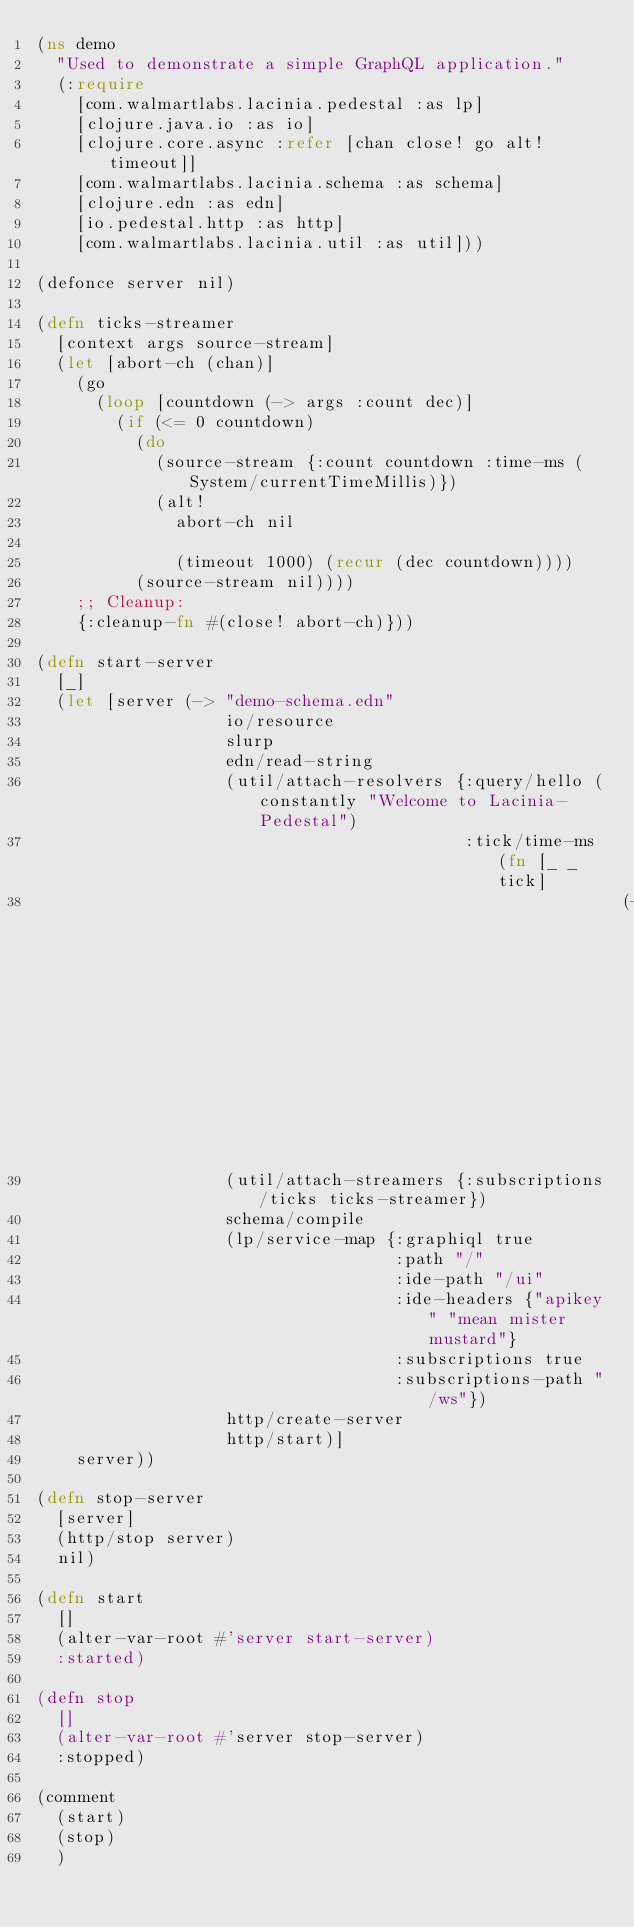<code> <loc_0><loc_0><loc_500><loc_500><_Clojure_>(ns demo
  "Used to demonstrate a simple GraphQL application."
  (:require
    [com.walmartlabs.lacinia.pedestal :as lp]
    [clojure.java.io :as io]
    [clojure.core.async :refer [chan close! go alt! timeout]]
    [com.walmartlabs.lacinia.schema :as schema]
    [clojure.edn :as edn]
    [io.pedestal.http :as http]
    [com.walmartlabs.lacinia.util :as util]))

(defonce server nil)

(defn ticks-streamer
  [context args source-stream]
  (let [abort-ch (chan)]
    (go
      (loop [countdown (-> args :count dec)]
        (if (<= 0 countdown)
          (do
            (source-stream {:count countdown :time-ms (System/currentTimeMillis)})
            (alt!
              abort-ch nil

              (timeout 1000) (recur (dec countdown))))
          (source-stream nil))))
    ;; Cleanup:
    {:cleanup-fn #(close! abort-ch)}))

(defn start-server
  [_]
  (let [server (-> "demo-schema.edn"
                   io/resource
                   slurp
                   edn/read-string
                   (util/attach-resolvers {:query/hello (constantly "Welcome to Lacinia-Pedestal")
                                           :tick/time-ms (fn [_ _ tick]
                                                           (-> tick :time-ms str))})
                   (util/attach-streamers {:subscriptions/ticks ticks-streamer})
                   schema/compile
                   (lp/service-map {:graphiql true
                                    :path "/"
                                    :ide-path "/ui"
                                    :ide-headers {"apikey" "mean mister mustard"}
                                    :subscriptions true
                                    :subscriptions-path "/ws"})
                   http/create-server
                   http/start)]
    server))

(defn stop-server
  [server]
  (http/stop server)
  nil)

(defn start
  []
  (alter-var-root #'server start-server)
  :started)

(defn stop
  []
  (alter-var-root #'server stop-server)
  :stopped)

(comment
  (start)
  (stop)
  )
</code> 